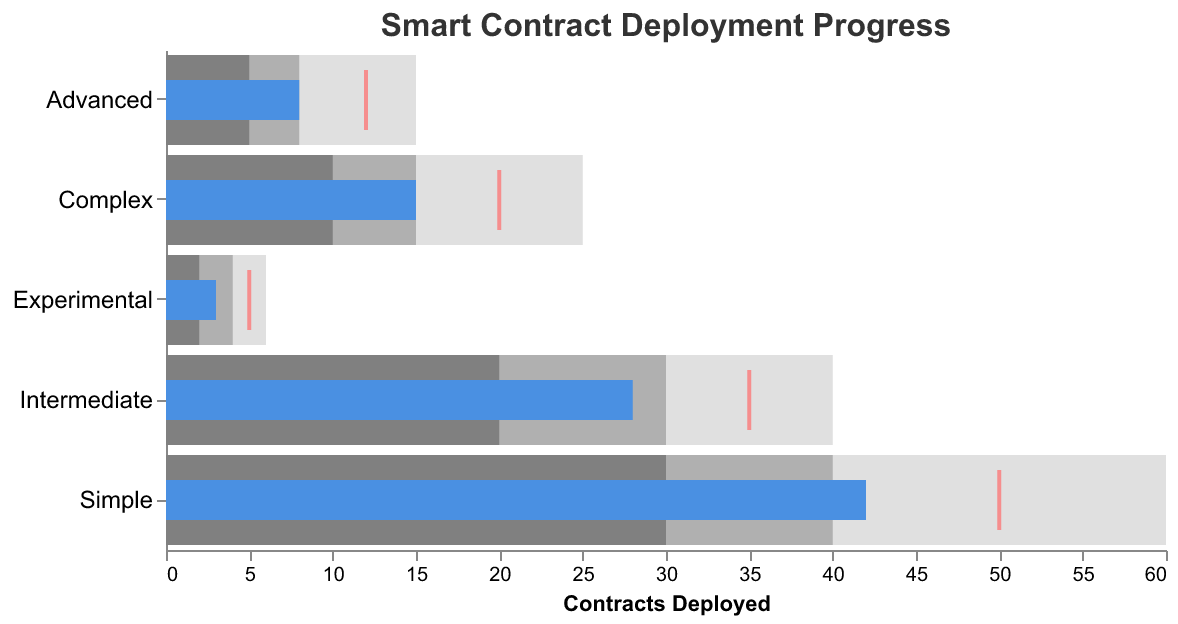What is the title of the chart? The title is clearly displayed at the top of the chart in plain text. It reads "Smart Contract Deployment Progress."
Answer: Smart Contract Deployment Progress How many contract types are displayed in the chart? By looking at the vertical axis, you can count the number of different labels representing contract types.
Answer: 5 Which contract type has the highest actual deployment count? Locate the longest blue bar representing "Actual" deployments. In this case, the longest blue bar corresponds to the "Simple" contract type.
Answer: Simple What is the target deployment count for Complex contracts? Locate the red tick mark on the horizontal axis for the "Complex" row. This tick mark represents the target count.
Answer: 20 What is the difference between the target and actual deployments for the Advanced contract type? Identify the red tick mark (target) and the end of the blue bar (actual) in the "Advanced" row. The target is 12, and the actual is 8. Subtract to find the difference.
Answer: 4 Which contract types have actual deployments that exceed their target? Compare the length of the blue bars (actual) with the position of the red ticks (target) for each contract type. Only the contract types where the blue bar extends beyond the red tick are considered.
Answer: Simple What is the total range for Intermediate contracts from the least to the highest value? Examine the lightest grey bar (Range3) indicating the highest value and the smallest value indicated by the start of the darkest grey bar (Range1). For Intermediate contracts, this range is from 20 to 40.
Answer: 20-40 Arrange the contract types in descending order based on their actual deployment values. Compare the lengths of all blue bars and order from longest to shortest: Simple (42), Intermediate (28), Complex (15), Advanced (8), Experimental (3).
Answer: Simple, Intermediate, Complex, Advanced, Experimental In which complexity category does the actual deployment exactly meet the target deployment? Examine where the end of the blue bar (actual) aligns precisely with the red tick (target).
Answer: None What range is labeled in the darkest grey color for the Experimental contract type? Observe the colors within each bar segment. The darkest grey represents Range1, which for Experimental contracts spans from 2 to 4.
Answer: 2-4 